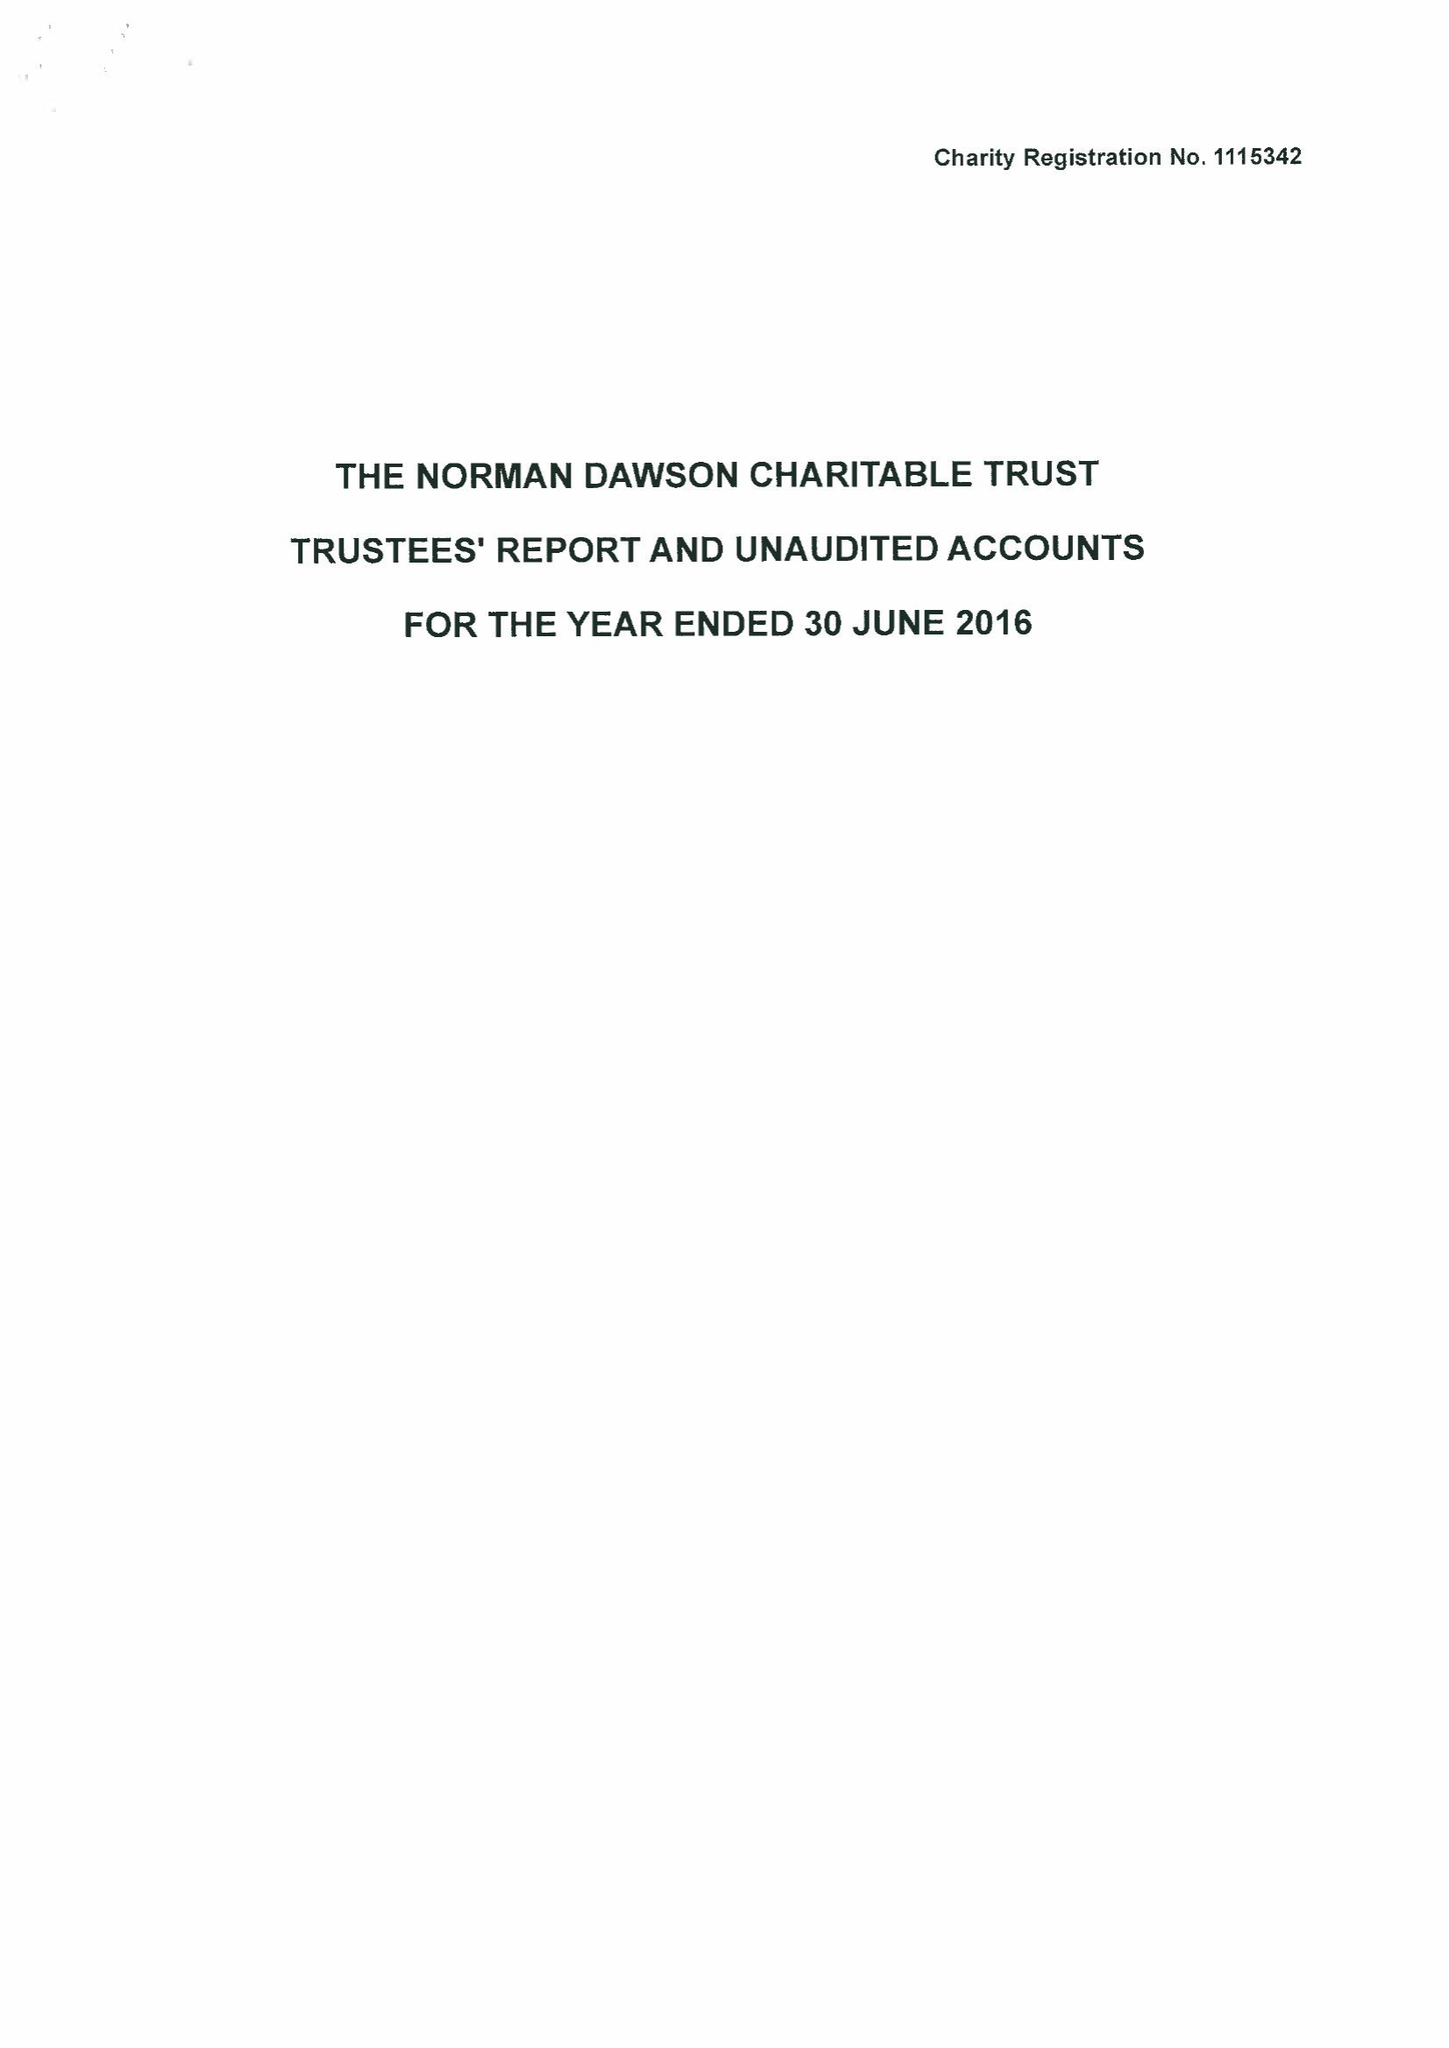What is the value for the income_annually_in_british_pounds?
Answer the question using a single word or phrase. 43593.00 